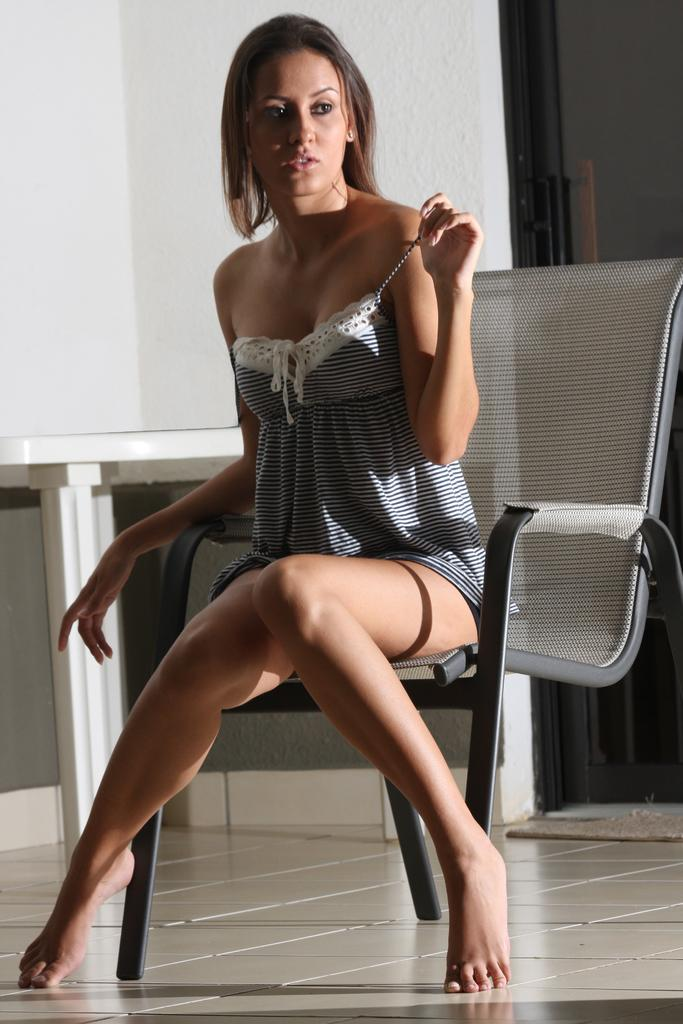Who is present in the image? There is a woman in the image. What is the woman doing in the image? The woman is sitting in a chair. What is the woman wearing in the image? The woman is wearing a dress. How many clocks are hanging on the wall behind the woman in the image? There are no clocks visible in the image. What type of stocking is the woman wearing on her legs in the image? The woman is not wearing any stockings in the image; she is wearing a dress. 